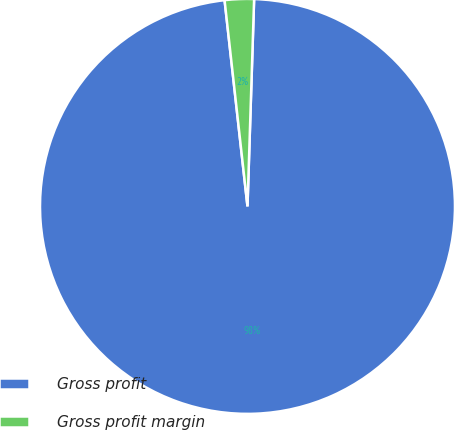Convert chart to OTSL. <chart><loc_0><loc_0><loc_500><loc_500><pie_chart><fcel>Gross profit<fcel>Gross profit margin<nl><fcel>97.73%<fcel>2.27%<nl></chart> 